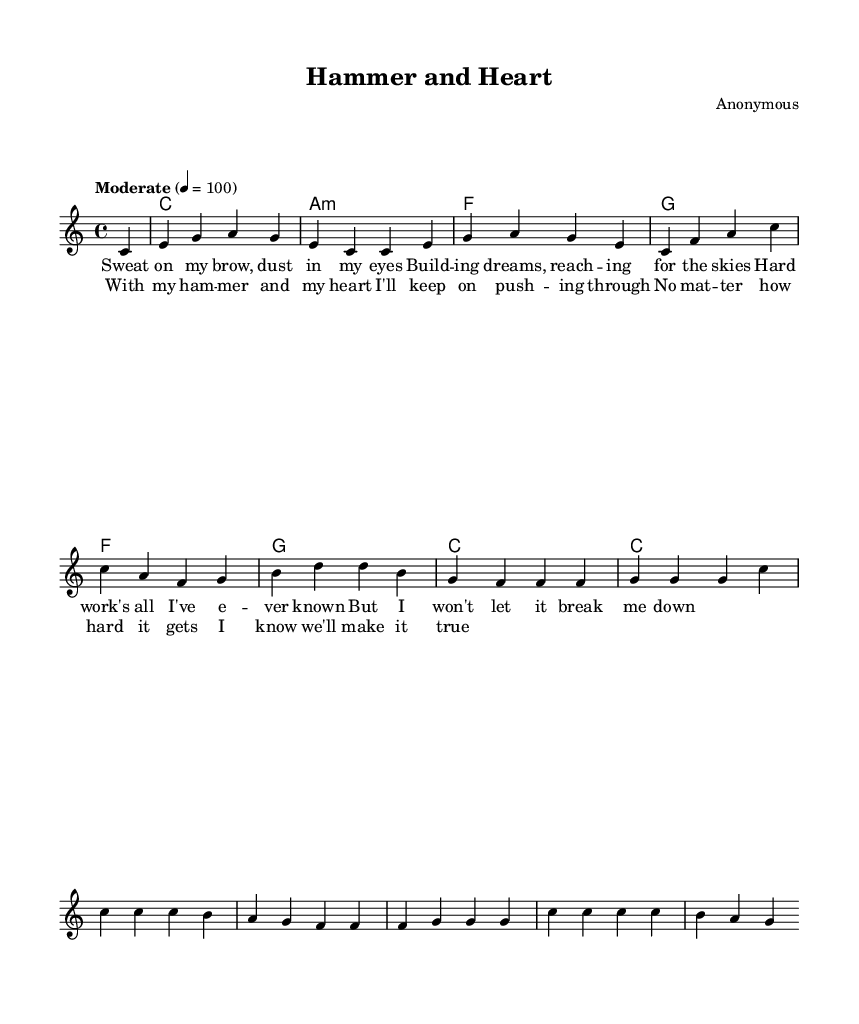What is the key signature of this music? The key signature indicated is C major, which has no sharps or flats. This can be determined by looking at the key indication in the sheet music at the beginning.
Answer: C major What is the time signature of this music? The time signature shown is 4/4, which is indicated at the start of the sheet music. This means there are four beats in each measure, and a quarter note gets one beat.
Answer: 4/4 What is the tempo marking for this piece? The tempo marking in the music is "Moderate" with a beat of quarter note equals 100. This specifies how fast the music should be played, which can be seen written above the staff.
Answer: Moderate How many measures are in the melody? By counting the measures in the melody section, which is separated by vertical lines, there are eight measures total. This gives an overview of the structure and flow of the melody.
Answer: 8 What type of rhythm is predominantly used in this song? The rhythm features a consistent quarter note pattern, which is common in many soul songs and can be inferred from the long strings of quarter notes throughout the melody section.
Answer: Quarter notes What are the themes presented in the lyrics? The lyrics express hard work, perseverance, and hope in the face of struggle, which is typical of classic soul music that resonates with working-class struggles. The lyrics indicate building dreams and pushing through tough times.
Answer: Hard work and perseverance What chords are used in the harmonies section? The chords used are C major, A minor, F major, and G major. These can be identified in the harmonies section, indicating a common chord progression used in many soul songs.
Answer: C, A minor, F, G 